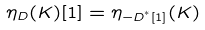Convert formula to latex. <formula><loc_0><loc_0><loc_500><loc_500>\eta _ { D } ( K ) [ 1 ] = \eta _ { - D ^ { ^ { * } } [ 1 ] } ( K )</formula> 